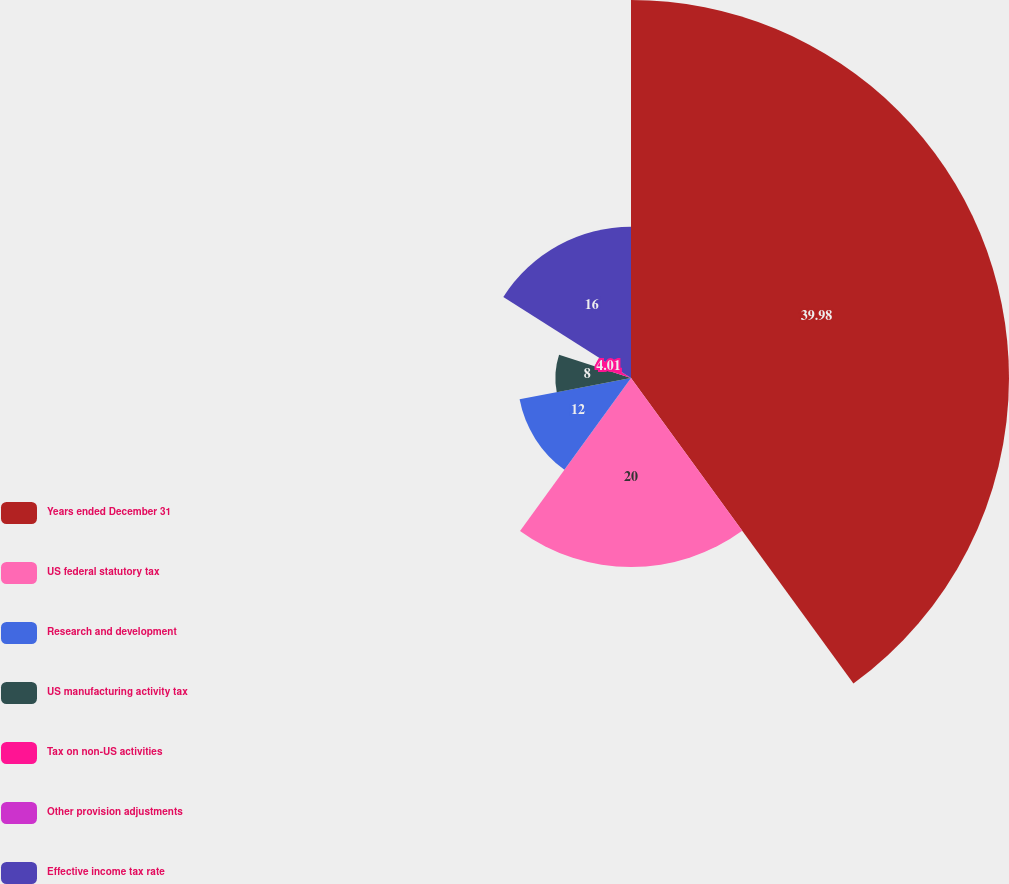Convert chart to OTSL. <chart><loc_0><loc_0><loc_500><loc_500><pie_chart><fcel>Years ended December 31<fcel>US federal statutory tax<fcel>Research and development<fcel>US manufacturing activity tax<fcel>Tax on non-US activities<fcel>Other provision adjustments<fcel>Effective income tax rate<nl><fcel>39.99%<fcel>20.0%<fcel>12.0%<fcel>8.0%<fcel>4.01%<fcel>0.01%<fcel>16.0%<nl></chart> 